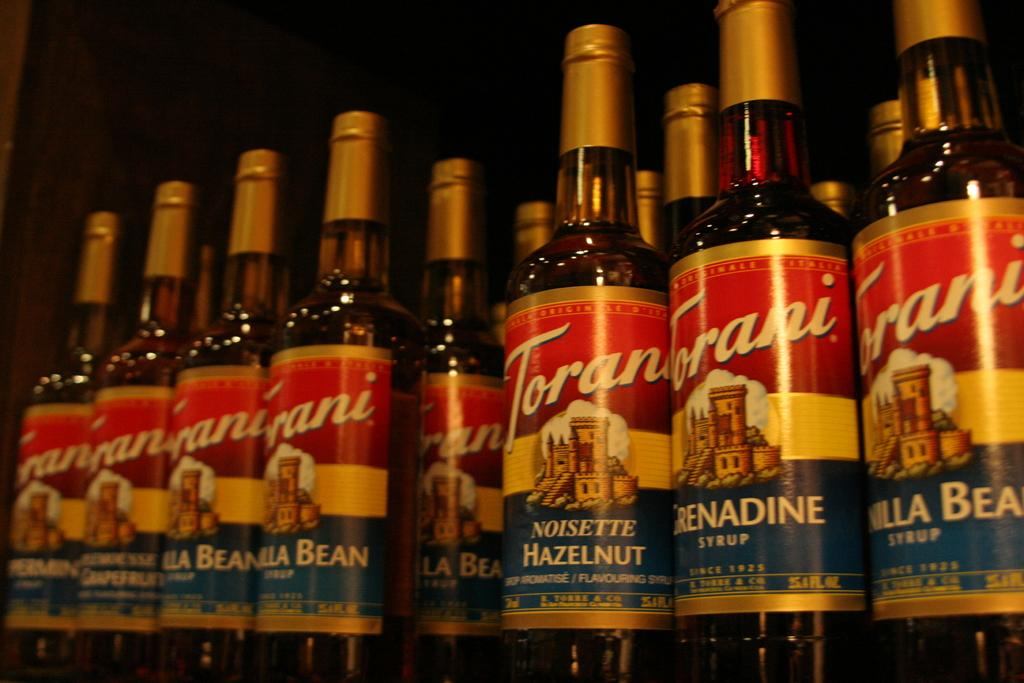<image>
Render a clear and concise summary of the photo. Several bottles of Hazlenut drink all stand side by side. 